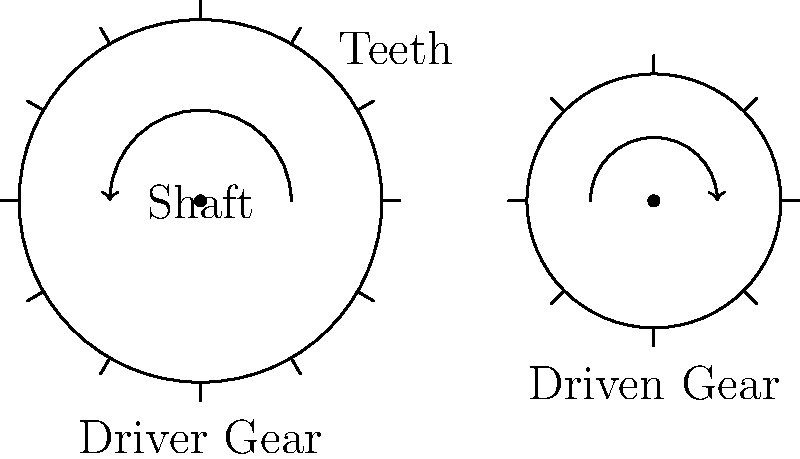In the simple machine shown above, if the driver gear completes one full rotation, how many rotations will the driven gear make? Express your answer as a fraction. To solve this problem, we need to understand how gears work together:

1. Count the number of teeth on each gear:
   - Driver gear: 12 teeth
   - Driven gear: 8 teeth

2. Understand the relationship between gear sizes and rotations:
   - When gears mesh, the number of teeth that pass a fixed point is the same for both gears.
   - This means that the number of rotations is inversely proportional to the number of teeth.

3. Set up the ratio:
   $\frac{\text{Driver rotations}}{\text{Driven rotations}} = \frac{\text{Driven teeth}}{\text{Driver teeth}}$

4. Plug in the values:
   $\frac{1}{\text{Driven rotations}} = \frac{8}{12}$

5. Solve for the driven rotations:
   $\text{Driven rotations} = \frac{12}{8} = \frac{3}{2}$

Therefore, when the driver gear makes one full rotation, the driven gear will make $\frac{3}{2}$ rotations.
Answer: $\frac{3}{2}$ 